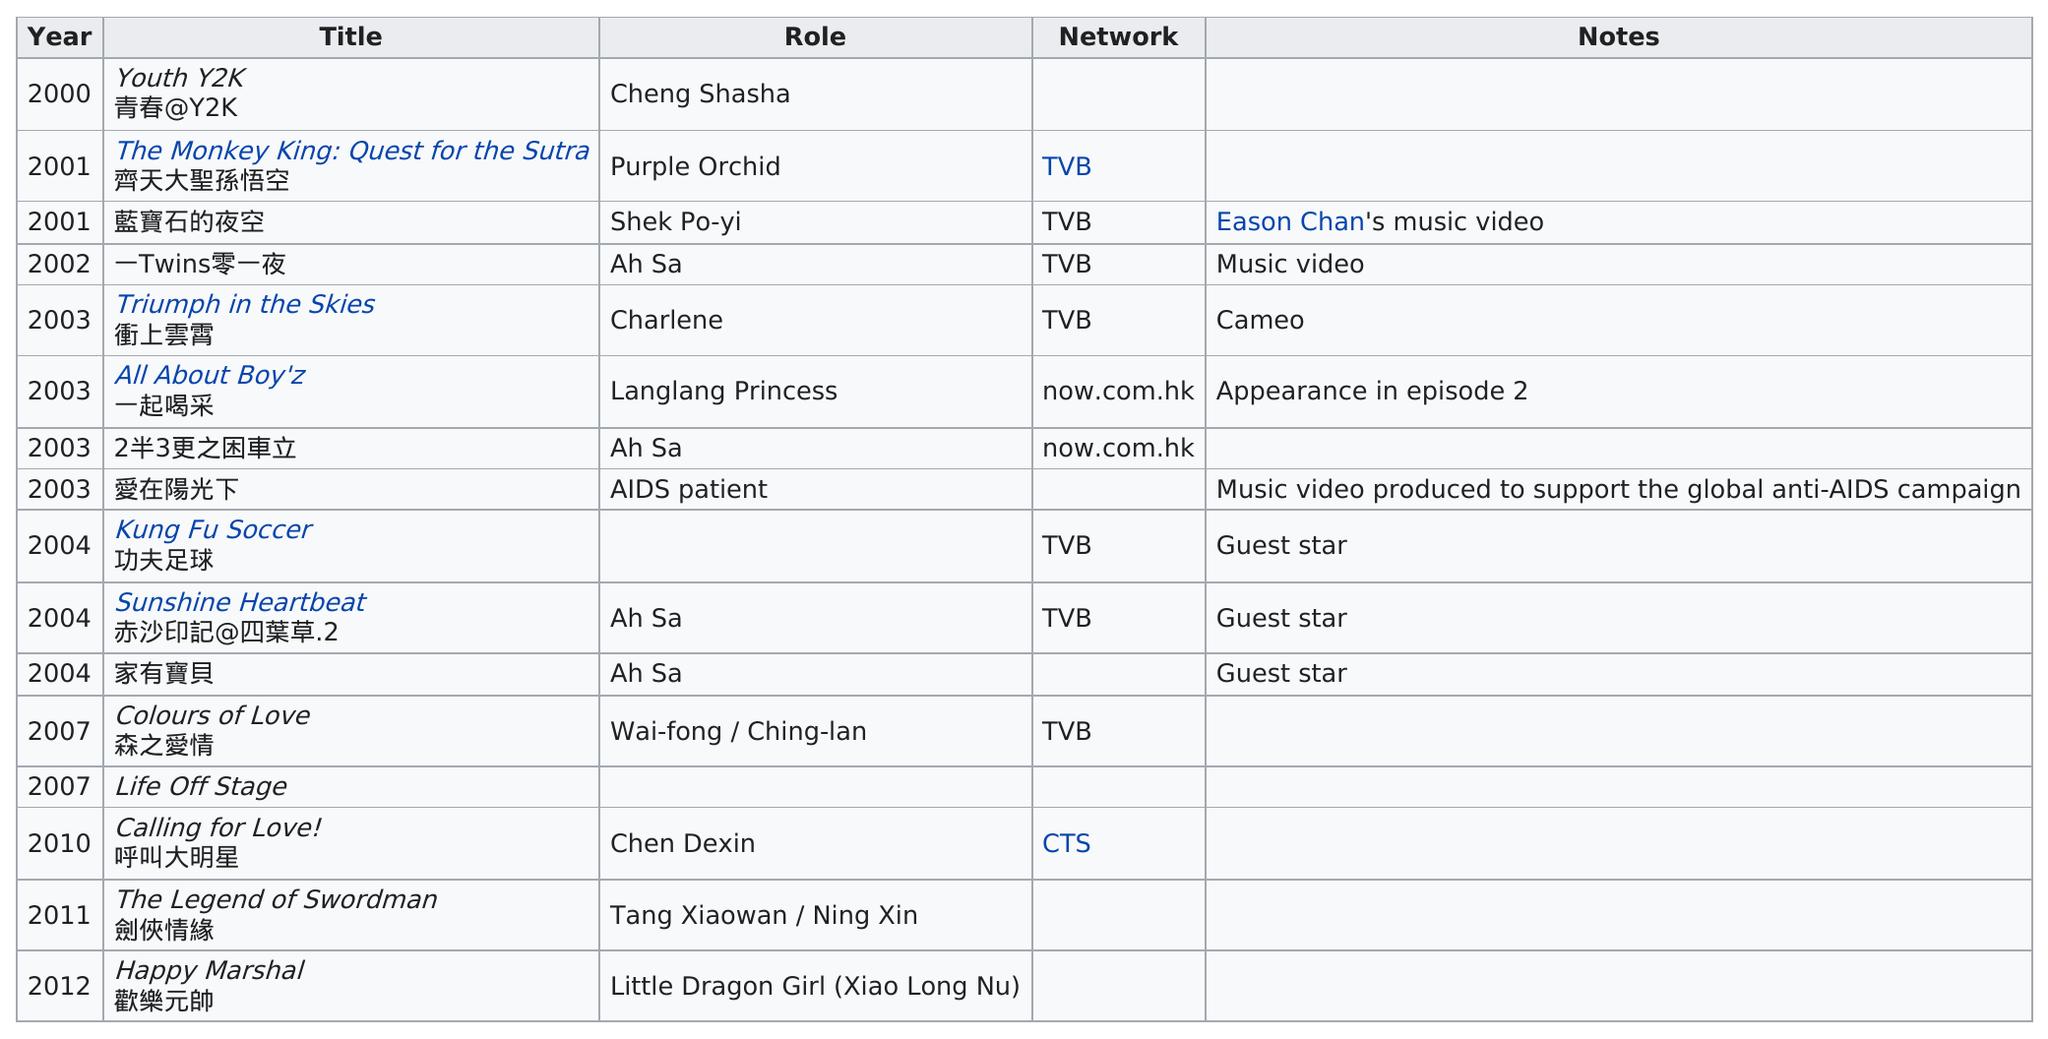Point out several critical features in this image. Seven appearances were made on the TVB network. In 10 years, there would have been an appearance on the CTS network. In the year 2003, 4 films were made. The titles of the TV show are not available for viewing. The only person to appear in episode 2 is the Langlang Princess. 